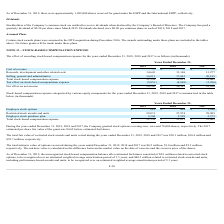According to Xperi Corporation's financial document, What is the estimated per share fair value of the granted stock options before estimated forfeitures in 2017? According to the financial document, $4.62. The relevant text states: "17 estimated per share fair value of the grant was $4.62 before estimated forfeitures...." Also, What is the total fair value of restricted stock awards and units in 2018 and 2017, respectively?  The document shows two values: $30.4 million and $22.7 million. From the document: "ecember 31, 2019, 2018 and 2017 was $30.1 million, $30.4 million and $22.7 million, respectively. 2018 and 2017 was $30.1 million, $30.4 million and $..." Also, How does the company calculate the intrinsic value? the difference between the market value on the date of exercise and the exercise price of the shares. The document states: "espectively. The intrinsic value is calculated as the difference between the market value on the date of exercise and the exercise price of the shares..." Also, can you calculate: What is the proportion of employee stock options and employee stock purchase plans over total stock-based compensation expense in 2018? To answer this question, I need to perform calculations using the financial data. The calculation is: (438+2,599)/31,011 , which equals 0.1. This is based on the information: "Employee stock options $ 219 $ 438 $ 1,980 Employee stock purchase plan 2,304 2,599 2,573 Total stock-based compensation expense 31,554 31,011 33,462..." The key data points involved are: 2,599, 31,011, 438. Also, can you calculate: What is the average total stock-based compensation expense for the last 3 years (2017 - 2019)? To answer this question, I need to perform calculations using the financial data. The calculation is: (31,554+31,011+33,462)/3 , which equals 32009 (in thousands). This is based on the information: "Total stock-based compensation expense 31,554 31,011 33,462 al stock-based compensation expense 31,554 31,011 33,462 Total stock-based compensation expense 31,554 31,011 33,462..." The key data points involved are: 31,011, 31,554, 33,462. Also, can you calculate: What is the percentage change in restricted stock awards and units’ expenses from 2018 to 2019? To answer this question, I need to perform calculations using the financial data. The calculation is: (29,031-27,974)/27,974 , which equals 3.78 (percentage). This is based on the information: "Restricted stock awards and units 29,031 27,974 28,909 Restricted stock awards and units 29,031 27,974 28,909..." The key data points involved are: 27,974, 29,031. 